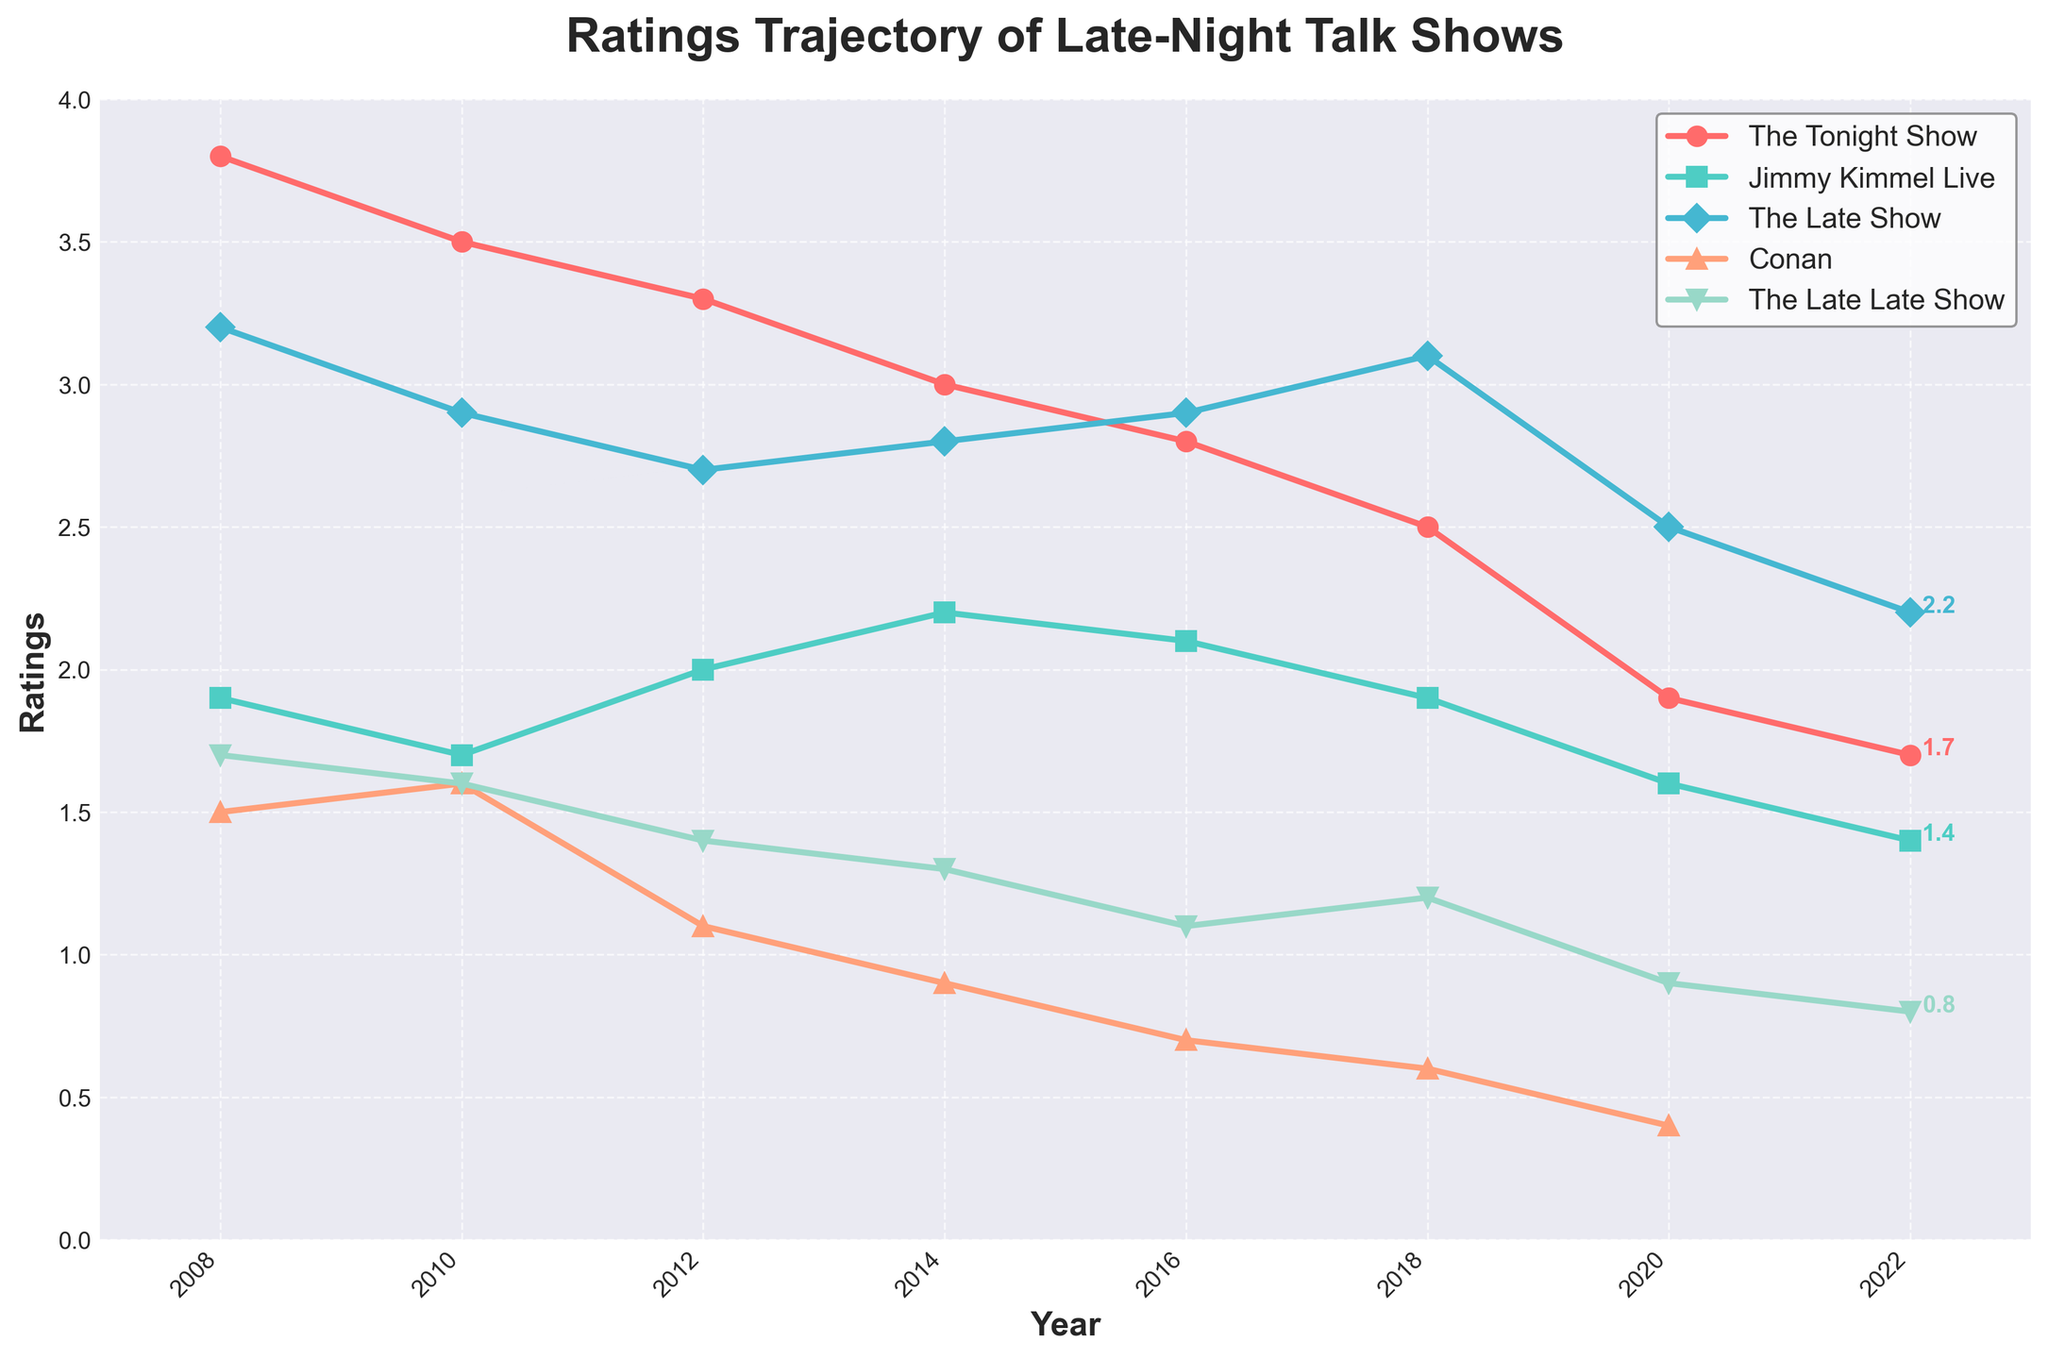Which talk show experienced the highest ratings in 2008? To determine which talk show had the highest ratings in 2008, compare the ratings for each show for that year given in the chart. The Tonight Show has the highest rating of 3.8 in 2008.
Answer: The Tonight Show Which talk shows had a reduction in ratings between 2016 and 2020? By comparing the ratings from 2016 and 2020, we look at each talk show to see if their ratings decreased. The Tonight Show, Jimmy Kimmel Live, The Late Show, Conan, and The Late Late Show all had reduced ratings in this period.
Answer: All of them Which talk show displayed the most stable ratings over the 15-year period? To find which show had the most stable ratings, compare the fluctuations of each show's ratings over the years. Jimmy Kimmel Live shows the least variation compared to others.
Answer: Jimmy Kimmel Live What is the difference in ratings between The Late Show and The Tonight Show in 2022? To find the difference, subtract the ratings of The Tonight Show from The Late Show in 2022. The Late Show has a rating of 2.2 and The Tonight Show has 1.7, so 2.2 - 1.7 = 0.5.
Answer: 0.5 Between 2020 and 2022, which talk show's ratings remained unchanged? To determine this, check the ratings for each show in 2020 and 2022 to see if any of them did not change. The Late Late Show had the same rating of 0.8 in both years.
Answer: The Late Late Show How many shows had ratings below 1.0 in 2020? Examine the ratings for 2020 and count the number of shows with ratings below 1.0. Conan and The Late Late Show both had ratings below 1.0.
Answer: 2 shows Which show had the highest rating drop from 2008 to 2022? Calculate the difference in ratings for each show between 2008 and 2022, and identify the one with the largest drop. The Tonight Show dropped from 3.8 in 2008 to 1.7 in 2022, a difference of 2.1, which is larger than any other show.
Answer: The Tonight Show In 2018, how did the ratings of The Late Show compare to The Tonight Show? Compare the ratings for The Late Show and The Tonight Show in 2018. The Late Show had a rating of 3.1, while The Tonight Show had 2.5.
Answer: The Late Show had higher ratings Which talk show consistently appeared in the ratings data until 2022? Identify which shows appear in every year listed in the ratings data until 2022. The Tonight Show, Jimmy Kimmel Live, and The Late Show appear in every year including 2022.
Answer: The Tonight Show, Jimmy Kimmel Live, The Late Show 